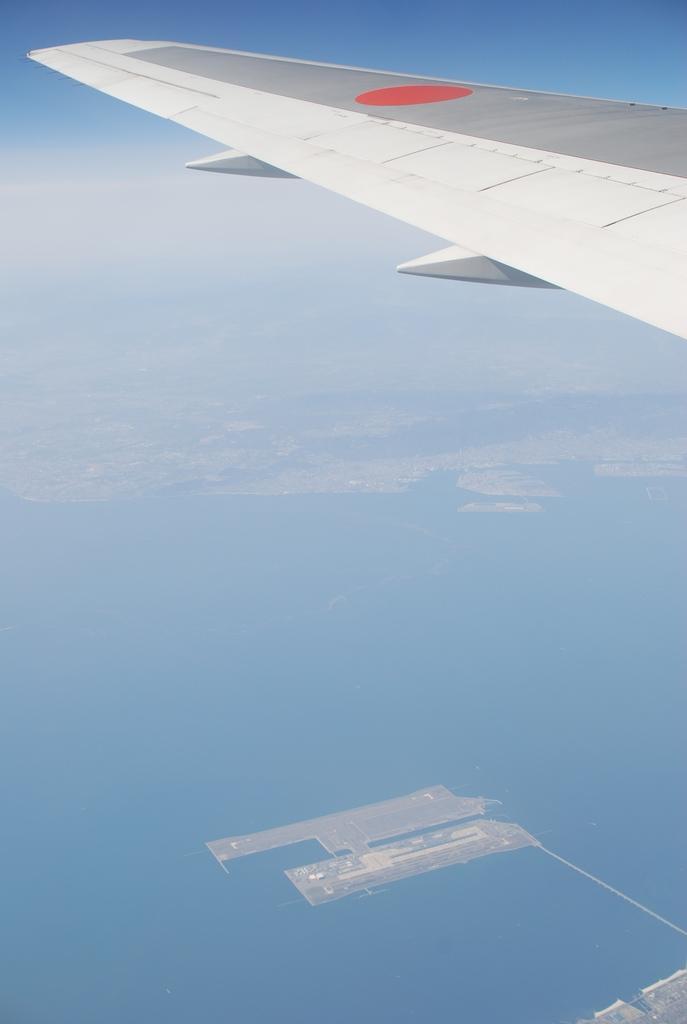Describe this image in one or two sentences. In this image we can see an aeroplane wing in the sky. This is a top view image we can see water, buildings, other objects and we can see clouds in the sky. 